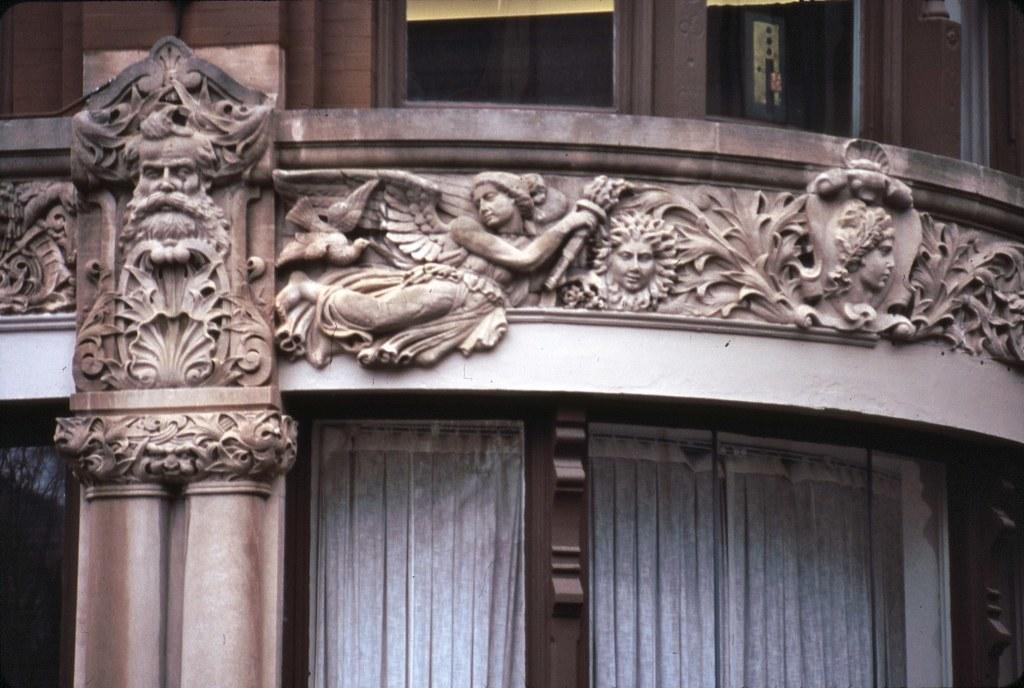What is on the wall in the image? There is a sculpture on the wall in the image. What can be seen in the background of the image? There are windows visible in the background of the image. What type of silk fabric is draped over the throne in the image? There is no throne or silk fabric present in the image; it only features a sculpture on the wall and windows in the background. 